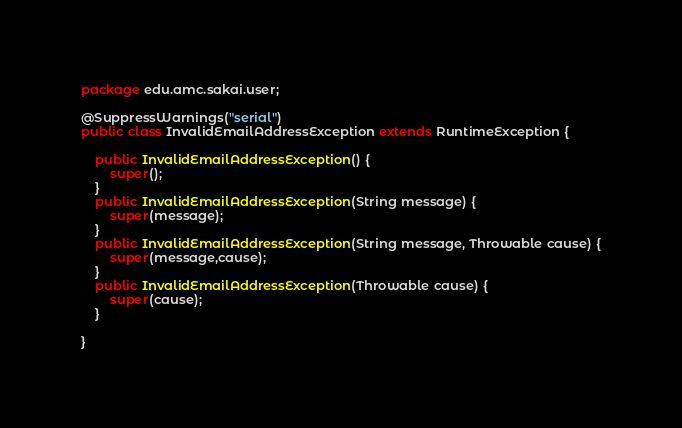Convert code to text. <code><loc_0><loc_0><loc_500><loc_500><_Java_>package edu.amc.sakai.user;

@SuppressWarnings("serial")
public class InvalidEmailAddressException extends RuntimeException {

	public InvalidEmailAddressException() {
		super();
	}
	public InvalidEmailAddressException(String message) {
		super(message);
	}
	public InvalidEmailAddressException(String message, Throwable cause) {
		super(message,cause);
	}
	public InvalidEmailAddressException(Throwable cause) {
		super(cause);
	}
	
}
</code> 